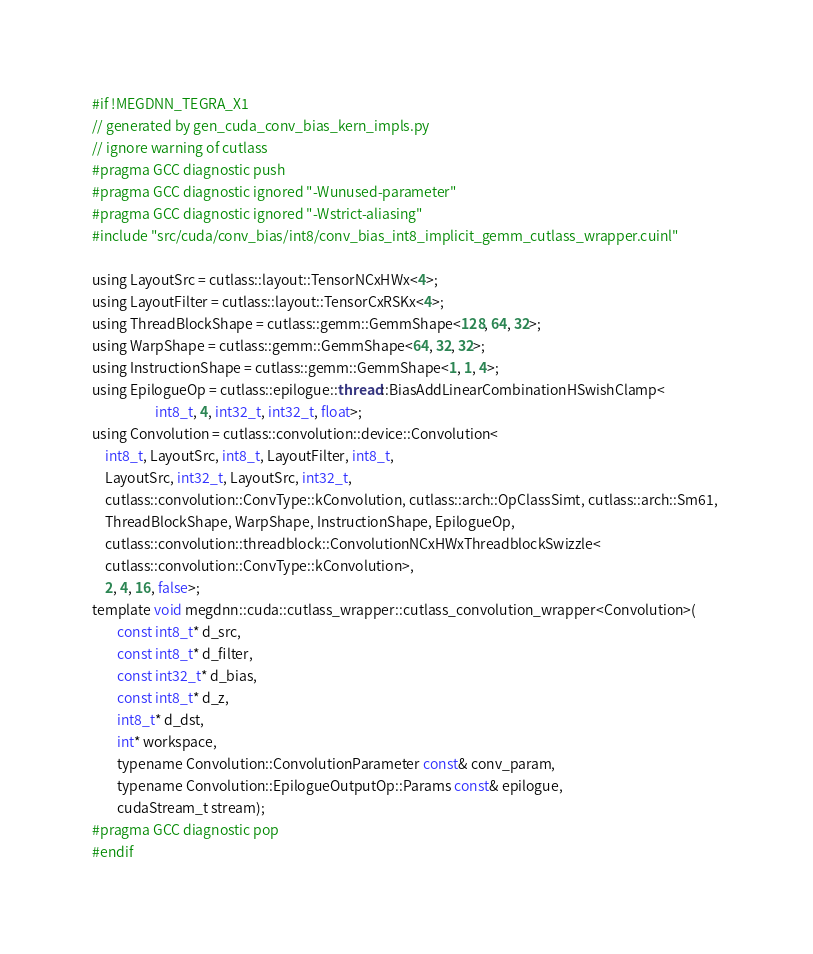<code> <loc_0><loc_0><loc_500><loc_500><_Cuda_>#if !MEGDNN_TEGRA_X1
// generated by gen_cuda_conv_bias_kern_impls.py
// ignore warning of cutlass
#pragma GCC diagnostic push
#pragma GCC diagnostic ignored "-Wunused-parameter"
#pragma GCC diagnostic ignored "-Wstrict-aliasing"
#include "src/cuda/conv_bias/int8/conv_bias_int8_implicit_gemm_cutlass_wrapper.cuinl"

using LayoutSrc = cutlass::layout::TensorNCxHWx<4>;
using LayoutFilter = cutlass::layout::TensorCxRSKx<4>;
using ThreadBlockShape = cutlass::gemm::GemmShape<128, 64, 32>;
using WarpShape = cutlass::gemm::GemmShape<64, 32, 32>;
using InstructionShape = cutlass::gemm::GemmShape<1, 1, 4>;
using EpilogueOp = cutlass::epilogue::thread::BiasAddLinearCombinationHSwishClamp<
                    int8_t, 4, int32_t, int32_t, float>;
using Convolution = cutlass::convolution::device::Convolution<
    int8_t, LayoutSrc, int8_t, LayoutFilter, int8_t, 
    LayoutSrc, int32_t, LayoutSrc, int32_t, 
    cutlass::convolution::ConvType::kConvolution, cutlass::arch::OpClassSimt, cutlass::arch::Sm61, 
    ThreadBlockShape, WarpShape, InstructionShape, EpilogueOp, 
    cutlass::convolution::threadblock::ConvolutionNCxHWxThreadblockSwizzle<
    cutlass::convolution::ConvType::kConvolution>, 
    2, 4, 16, false>;
template void megdnn::cuda::cutlass_wrapper::cutlass_convolution_wrapper<Convolution>(
        const int8_t* d_src, 
        const int8_t* d_filter, 
        const int32_t* d_bias, 
        const int8_t* d_z, 
        int8_t* d_dst, 
        int* workspace, 
        typename Convolution::ConvolutionParameter const& conv_param, 
        typename Convolution::EpilogueOutputOp::Params const& epilogue, 
        cudaStream_t stream);
#pragma GCC diagnostic pop
#endif
</code> 